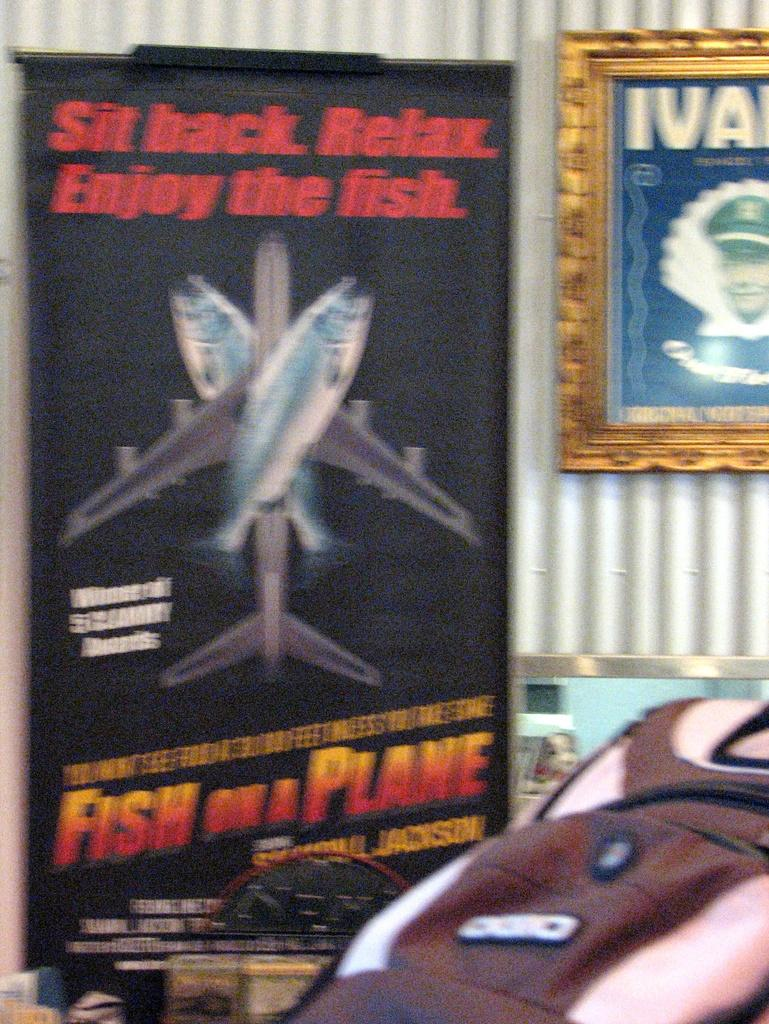<image>
Create a compact narrative representing the image presented. A tag line of "Fish on a Plane"is on a poster. 